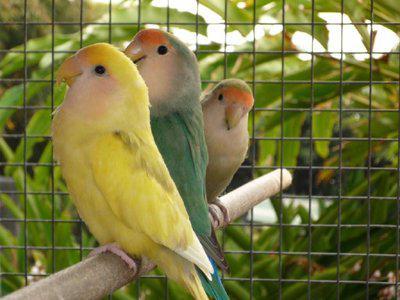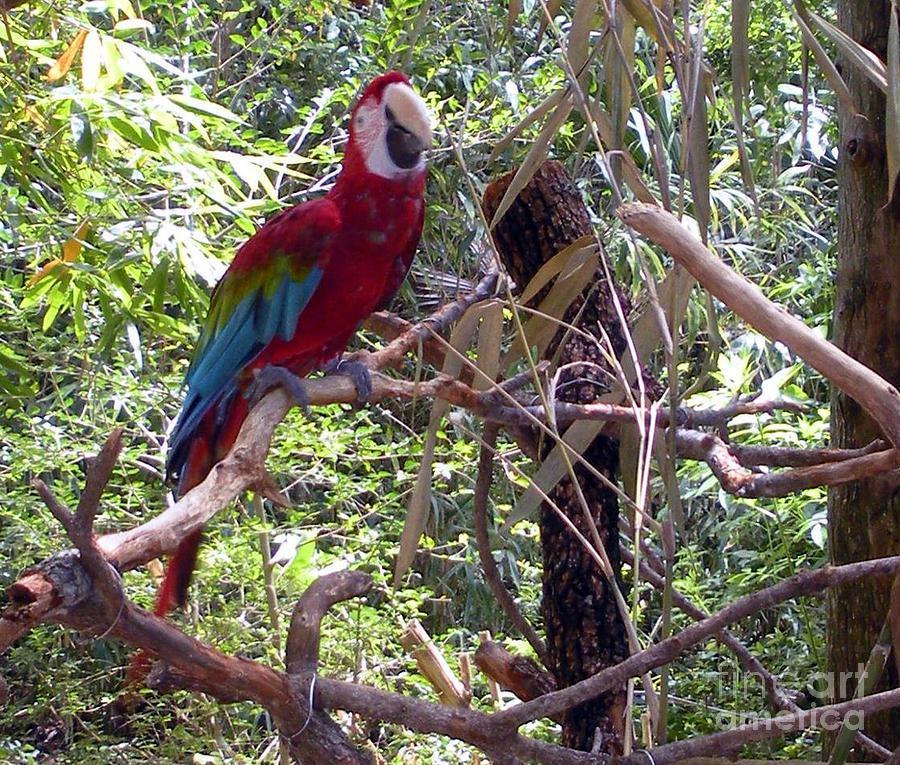The first image is the image on the left, the second image is the image on the right. Given the left and right images, does the statement "There is at least one image where there is a cage." hold true? Answer yes or no. Yes. 